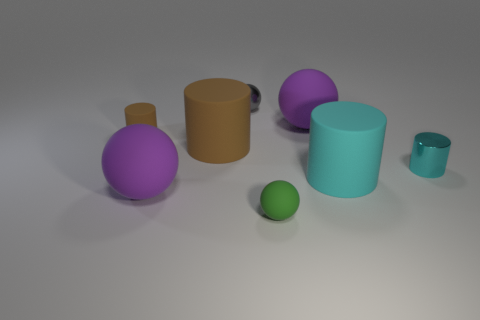Subtract all tiny gray shiny spheres. How many spheres are left? 3 Subtract all gray spheres. How many spheres are left? 3 Subtract 2 cylinders. How many cylinders are left? 2 Add 2 small brown matte cylinders. How many objects exist? 10 Subtract all red balls. Subtract all blue cylinders. How many balls are left? 4 Subtract 0 green cylinders. How many objects are left? 8 Subtract all small purple matte cylinders. Subtract all brown matte things. How many objects are left? 6 Add 8 small gray things. How many small gray things are left? 9 Add 8 cyan metal cylinders. How many cyan metal cylinders exist? 9 